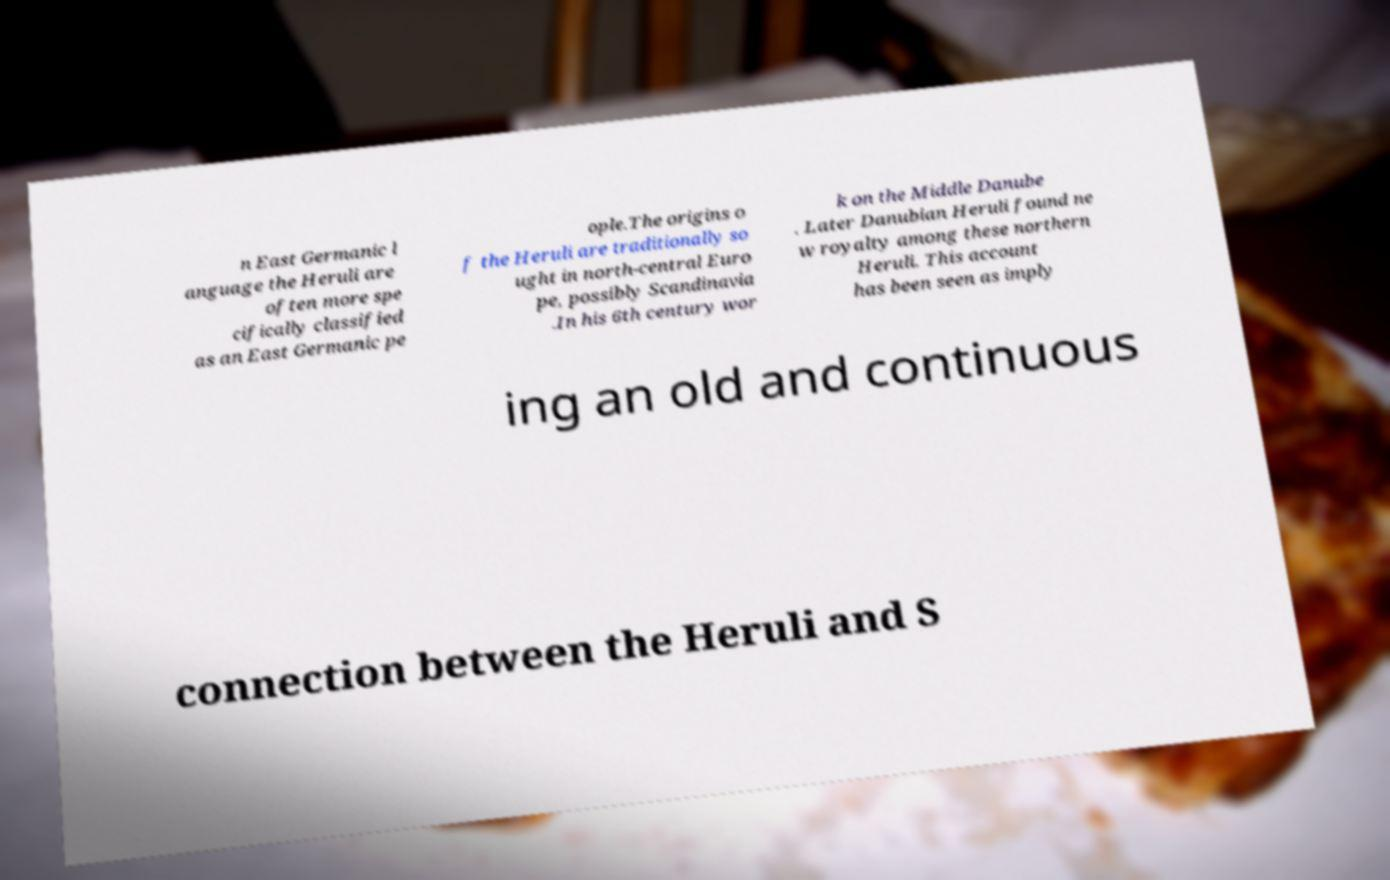What messages or text are displayed in this image? I need them in a readable, typed format. n East Germanic l anguage the Heruli are often more spe cifically classified as an East Germanic pe ople.The origins o f the Heruli are traditionally so ught in north-central Euro pe, possibly Scandinavia .In his 6th century wor k on the Middle Danube . Later Danubian Heruli found ne w royalty among these northern Heruli. This account has been seen as imply ing an old and continuous connection between the Heruli and S 